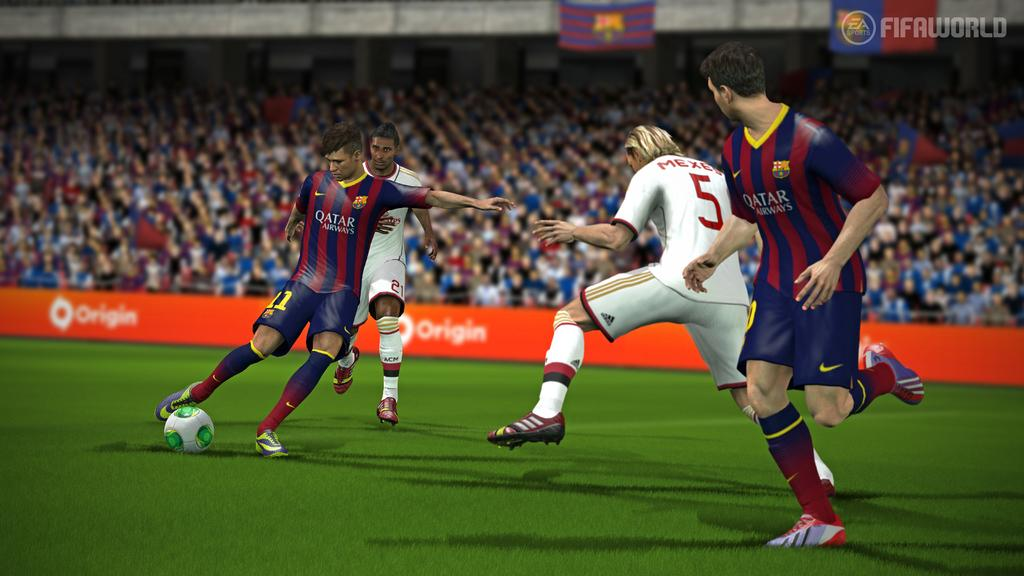<image>
Provide a brief description of the given image. Mexes looks to defend a soccer pass in a video game. 